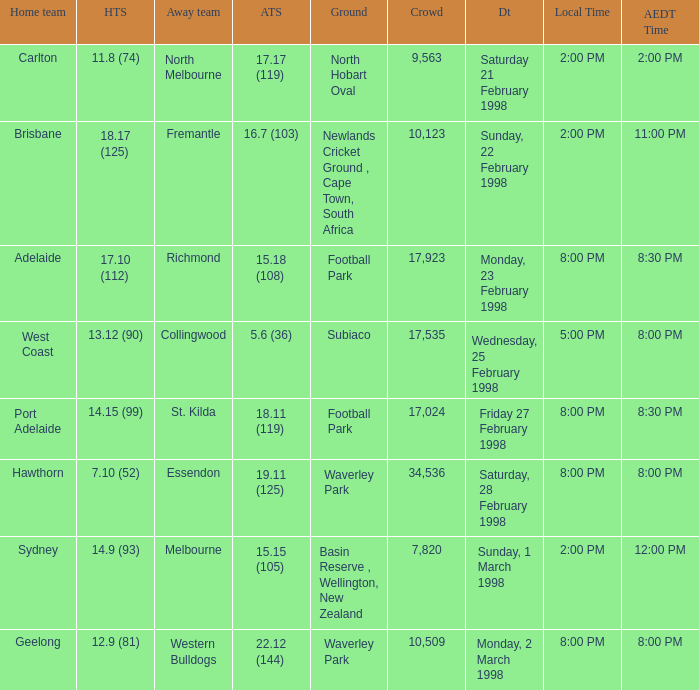Which Home team is on Wednesday, 25 february 1998? West Coast. 